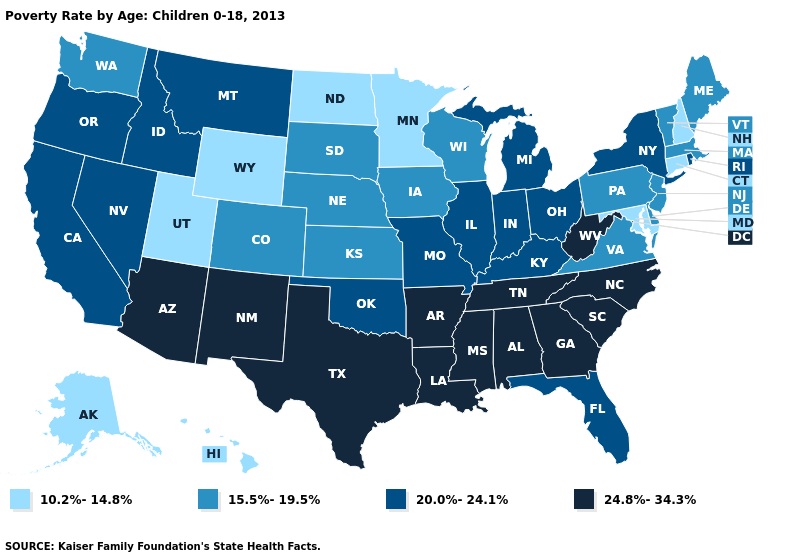What is the value of New Hampshire?
Be succinct. 10.2%-14.8%. How many symbols are there in the legend?
Answer briefly. 4. What is the highest value in the MidWest ?
Quick response, please. 20.0%-24.1%. What is the value of Georgia?
Concise answer only. 24.8%-34.3%. What is the lowest value in states that border Colorado?
Give a very brief answer. 10.2%-14.8%. What is the value of Vermont?
Give a very brief answer. 15.5%-19.5%. Is the legend a continuous bar?
Give a very brief answer. No. Does the map have missing data?
Quick response, please. No. Name the states that have a value in the range 20.0%-24.1%?
Answer briefly. California, Florida, Idaho, Illinois, Indiana, Kentucky, Michigan, Missouri, Montana, Nevada, New York, Ohio, Oklahoma, Oregon, Rhode Island. Does Indiana have a higher value than Louisiana?
Be succinct. No. Does the map have missing data?
Short answer required. No. Which states have the lowest value in the West?
Give a very brief answer. Alaska, Hawaii, Utah, Wyoming. Is the legend a continuous bar?
Write a very short answer. No. What is the lowest value in the USA?
Keep it brief. 10.2%-14.8%. Which states have the highest value in the USA?
Be succinct. Alabama, Arizona, Arkansas, Georgia, Louisiana, Mississippi, New Mexico, North Carolina, South Carolina, Tennessee, Texas, West Virginia. 